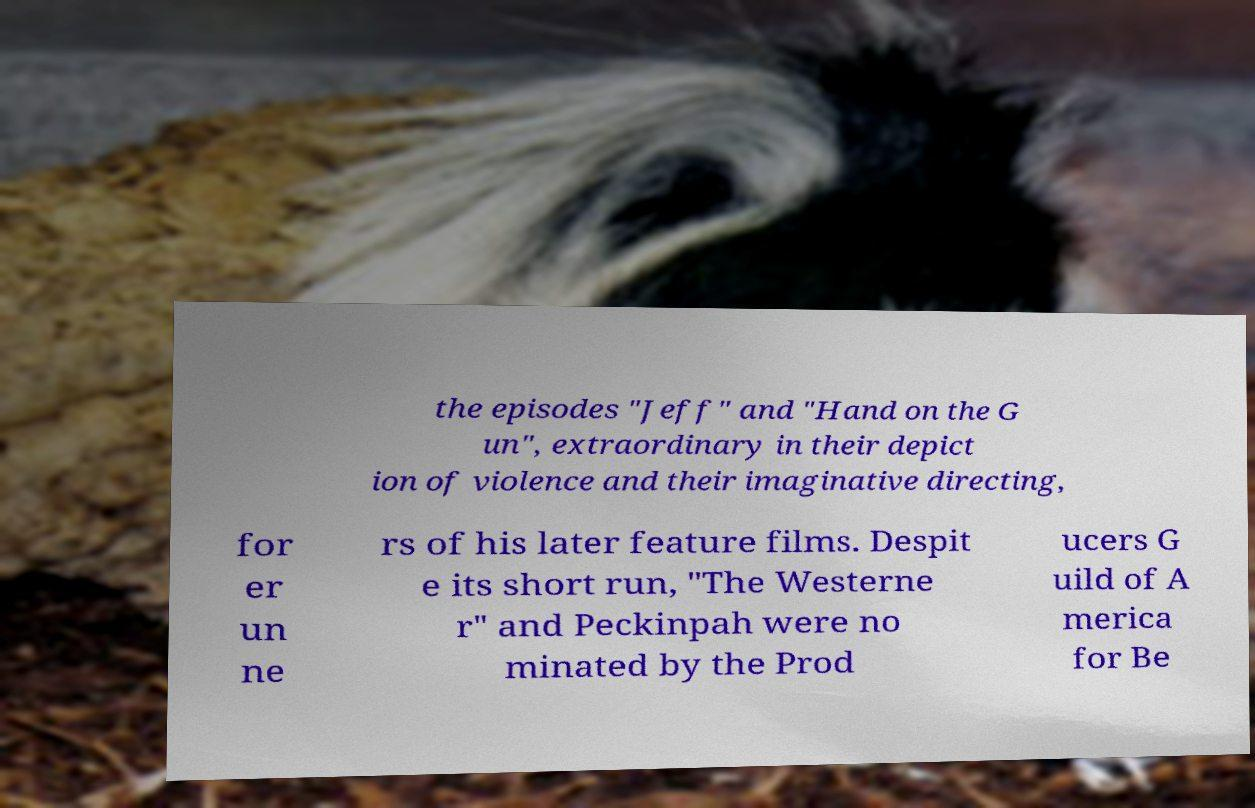There's text embedded in this image that I need extracted. Can you transcribe it verbatim? the episodes "Jeff" and "Hand on the G un", extraordinary in their depict ion of violence and their imaginative directing, for er un ne rs of his later feature films. Despit e its short run, "The Westerne r" and Peckinpah were no minated by the Prod ucers G uild of A merica for Be 